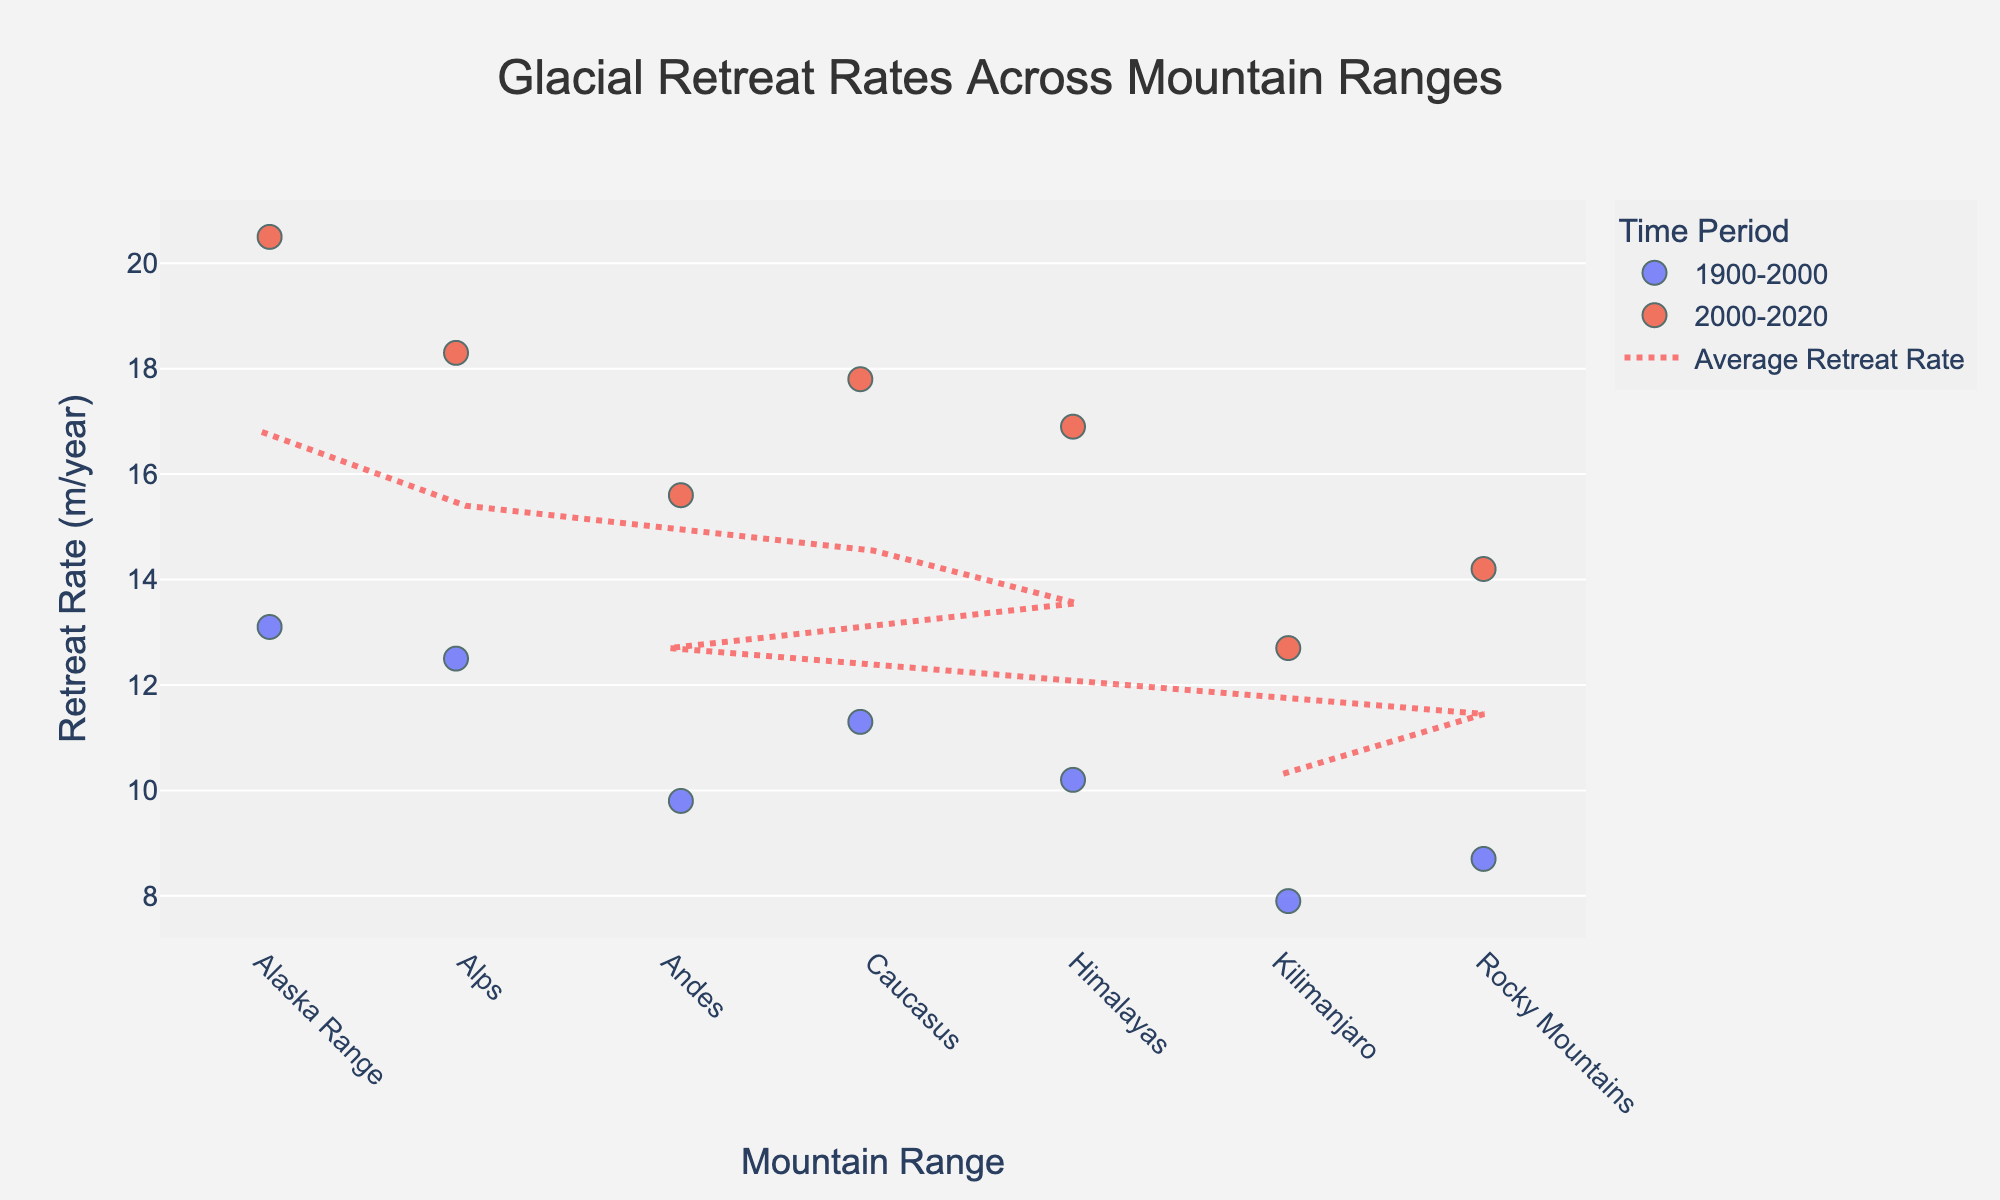What is the title of the plot? The title of the plot is displayed prominently at the top and is easy to read. The title reads "Glacial Retreat Rates Across Mountain Ranges".
Answer: Glacial Retreat Rates Across Mountain Ranges Which mountain range has the highest average retreat rate over the given periods? To find the mountain range with the highest average retreat rate, look at the red dotted line representing the average values. The Alaska Range has the highest average retreat rate.
Answer: Alaska Range How does the retreat rate in the Alps change between the two time periods? To observe the change, compare the retreat rates of the Alps in the two time periods shown by different color points. The retreat rate increases from 12.5 m/year in 1900-2000 to 18.3 m/year in 2000-2020.
Answer: It increases Which mountain range has the smallest change in retreat rate between the two time periods? Compare the differences in retreat rates between the two time periods for each mountain range. Kilimanjaro shows the smallest change, with an increase from 7.9 m/year to 12.7 m/year, a difference of 4.8 m/year.
Answer: Kilimanjaro For the time period 2000-2020, which mountain range has the lowest retreat rate? Look at the points marked for the time period 2000-2020 and identify the lowest value. Kilimanjaro has the lowest retreat rate of 12.7 m/year during this period.
Answer: Kilimanjaro Rank the mountain ranges based on their retreat rates in the time period 1900-2000 from highest to lowest. Arrange the retreat rates in the specified time period in descending order. Alaska Range (13.1 m/year) > Alps (12.5 m/year) > Caucasus (11.3 m/year) > Himalayas (10.2 m/year) > Andes (9.8 m/year) > Rocky Mountains (8.7 m/year) > Kilimanjaro (7.9 m/year).
Answer: Alaska Range, Alps, Caucasus, Himalayas, Andes, Rocky Mountains, Kilimanjaro How do the retreat rates compare between the Andes and the Himalayas for the period 2000-2020? Compare the retreat rates for the Andes and the Himalayas within the time period 2000-2020. The retreat rate for the Andes is 15.6 m/year, and for the Himalayas, it is 16.9 m/year. The Himalayas have a higher retreat rate.
Answer: Himalayas have a higher rate Is there an overall trend in how the retreat rates have changed from the period 1900-2000 to 2000-2020 across all mountain ranges? By looking at the data points for both time periods across all mountain ranges, we see that the retreat rates have generally increased in the later period (2000-2020) compared to the earlier period (1900-2000).
Answer: The rates generally increased What is the average retreat rate for the Rocky Mountains across both time periods? For the Rocky Mountains, the retreat rates are 8.7 m/year and 14.2 m/year for the two time periods. The average is calculated as (8.7 + 14.2) / 2 = 11.45 m/year.
Answer: 11.45 m/year 